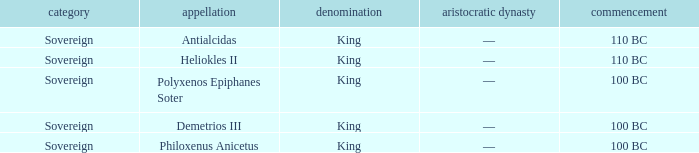When did Demetrios III begin to hold power? 100 BC. 